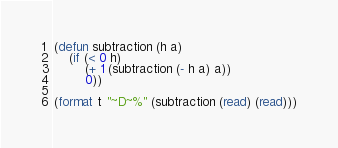<code> <loc_0><loc_0><loc_500><loc_500><_Lisp_>(defun subtraction (h a)
  	(if (< 0 h)
        (+ 1 (subtraction (- h a) a))
        0))

(format t "~D~%" (subtraction (read) (read)))</code> 